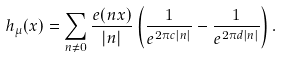<formula> <loc_0><loc_0><loc_500><loc_500>h _ { \mu } ( x ) = \sum _ { n \neq 0 } \frac { e ( n x ) } { | n | } \left ( \frac { 1 } { e ^ { 2 \pi c | n | } } - \frac { 1 } { e ^ { 2 \pi d | n | } } \right ) .</formula> 